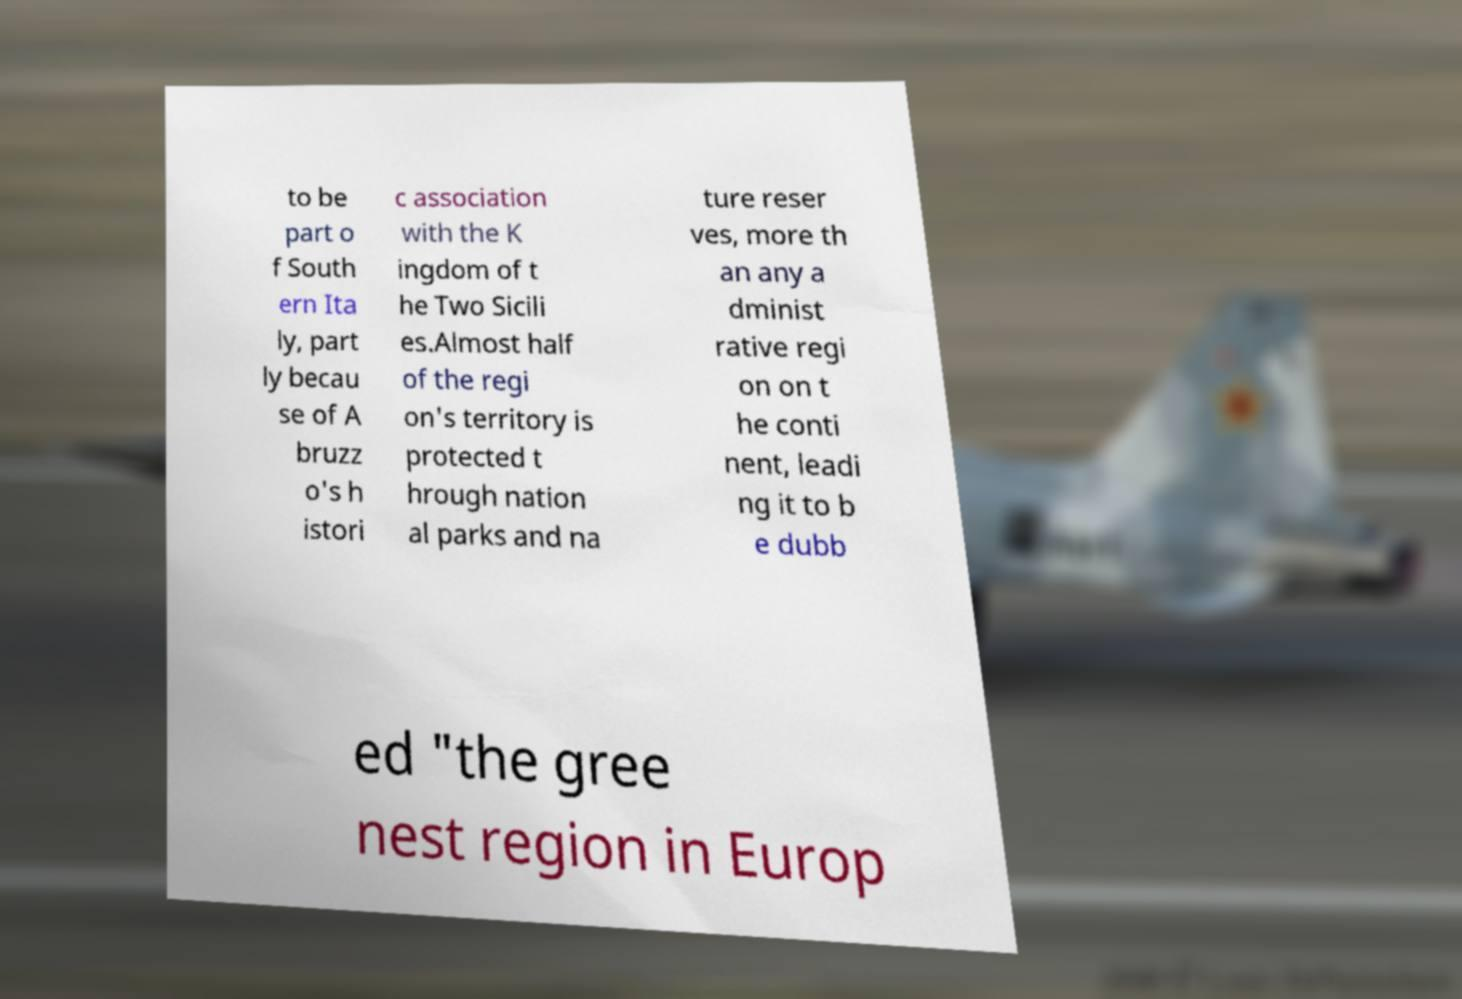What messages or text are displayed in this image? I need them in a readable, typed format. to be part o f South ern Ita ly, part ly becau se of A bruzz o's h istori c association with the K ingdom of t he Two Sicili es.Almost half of the regi on's territory is protected t hrough nation al parks and na ture reser ves, more th an any a dminist rative regi on on t he conti nent, leadi ng it to b e dubb ed "the gree nest region in Europ 